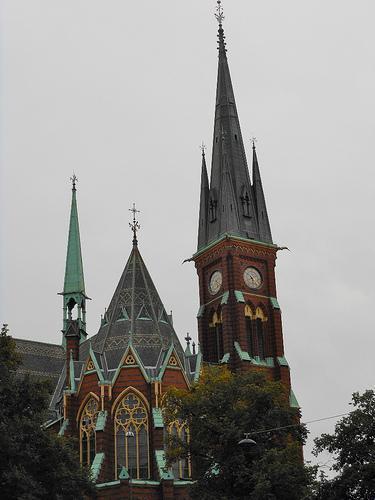How many big windows on the building in front?
Give a very brief answer. 3. How many buildings are in the picture?
Give a very brief answer. 1. How many trees are shown?
Give a very brief answer. 3. How many towers are shown?
Give a very brief answer. 3. 